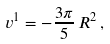<formula> <loc_0><loc_0><loc_500><loc_500>v ^ { 1 } = - \frac { 3 \pi } { 5 } \, R ^ { 2 } \, ,</formula> 